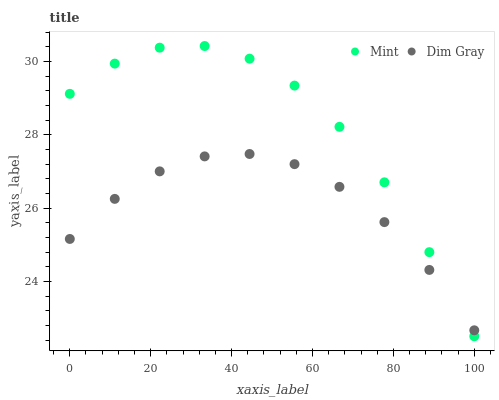Does Dim Gray have the minimum area under the curve?
Answer yes or no. Yes. Does Mint have the maximum area under the curve?
Answer yes or no. Yes. Does Mint have the minimum area under the curve?
Answer yes or no. No. Is Dim Gray the smoothest?
Answer yes or no. Yes. Is Mint the roughest?
Answer yes or no. Yes. Is Mint the smoothest?
Answer yes or no. No. Does Mint have the lowest value?
Answer yes or no. Yes. Does Mint have the highest value?
Answer yes or no. Yes. Does Dim Gray intersect Mint?
Answer yes or no. Yes. Is Dim Gray less than Mint?
Answer yes or no. No. Is Dim Gray greater than Mint?
Answer yes or no. No. 